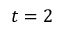<formula> <loc_0><loc_0><loc_500><loc_500>t = 2</formula> 